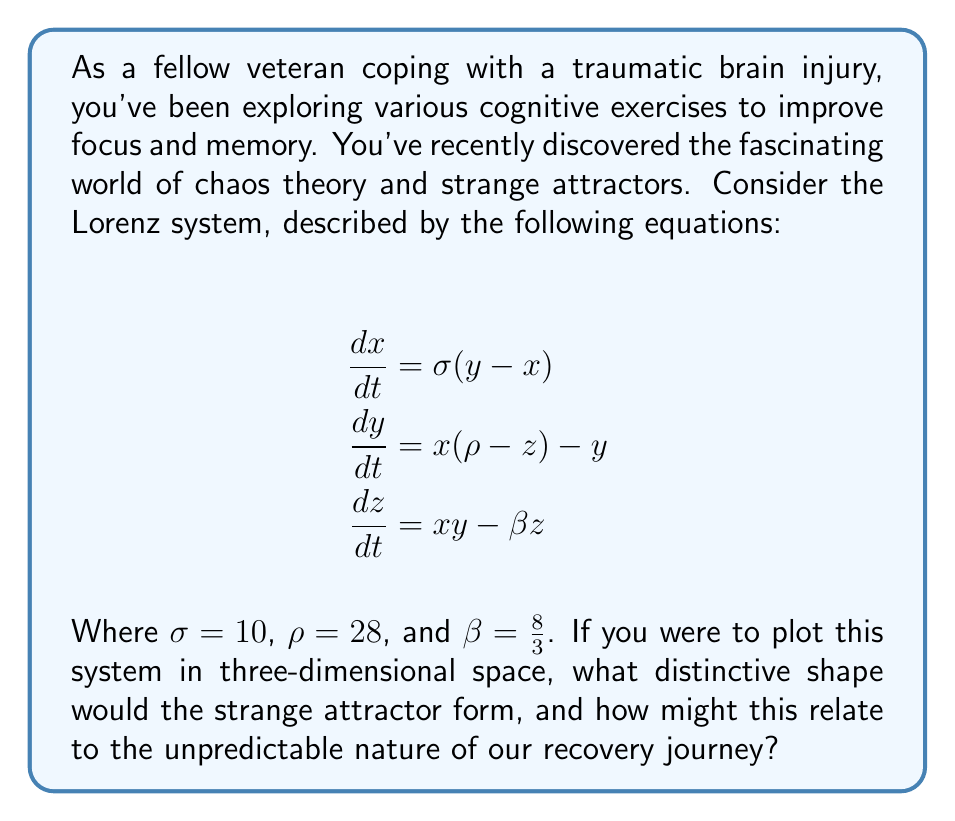Can you answer this question? To understand the shape of the strange attractor in the Lorenz system, let's break down the problem step-by-step:

1) The Lorenz system is a set of three coupled, nonlinear differential equations that describe atmospheric convection.

2) When we plot the solutions to these equations in three-dimensional space (with x, y, and z as the axes), we get a trajectory that never repeats exactly but stays within a bounded region.

3) This bounded region forms a distinctive shape known as the Lorenz attractor.

4) The shape of the Lorenz attractor resembles a butterfly or a figure-eight. It consists of two lobes that the trajectory spirals around, occasionally switching from one lobe to the other.

5) This shape emerges due to the system's sensitivity to initial conditions, a hallmark of chaotic systems.

6) The butterfly-like shape is symbolic of the "butterfly effect" in chaos theory, where small changes in initial conditions can lead to vastly different outcomes.

7) In the context of our recovery journey, this shape can be seen as a metaphor for the unpredictable nature of healing from a traumatic brain injury:

   - Just as the trajectory never repeats exactly but stays within a bounded region, our recovery may have ups and downs but generally progresses within certain limits.
   - The switching between lobes could represent good days and bad days in our recovery process.
   - The sensitivity to initial conditions mirrors how small changes in our daily routines or treatments can sometimes lead to significant differences in our progress.

8) Understanding this concept can help us appreciate the complexity of our recovery journey and the importance of perseverance, even when progress seems chaotic or unpredictable.
Answer: Butterfly-shaped attractor 